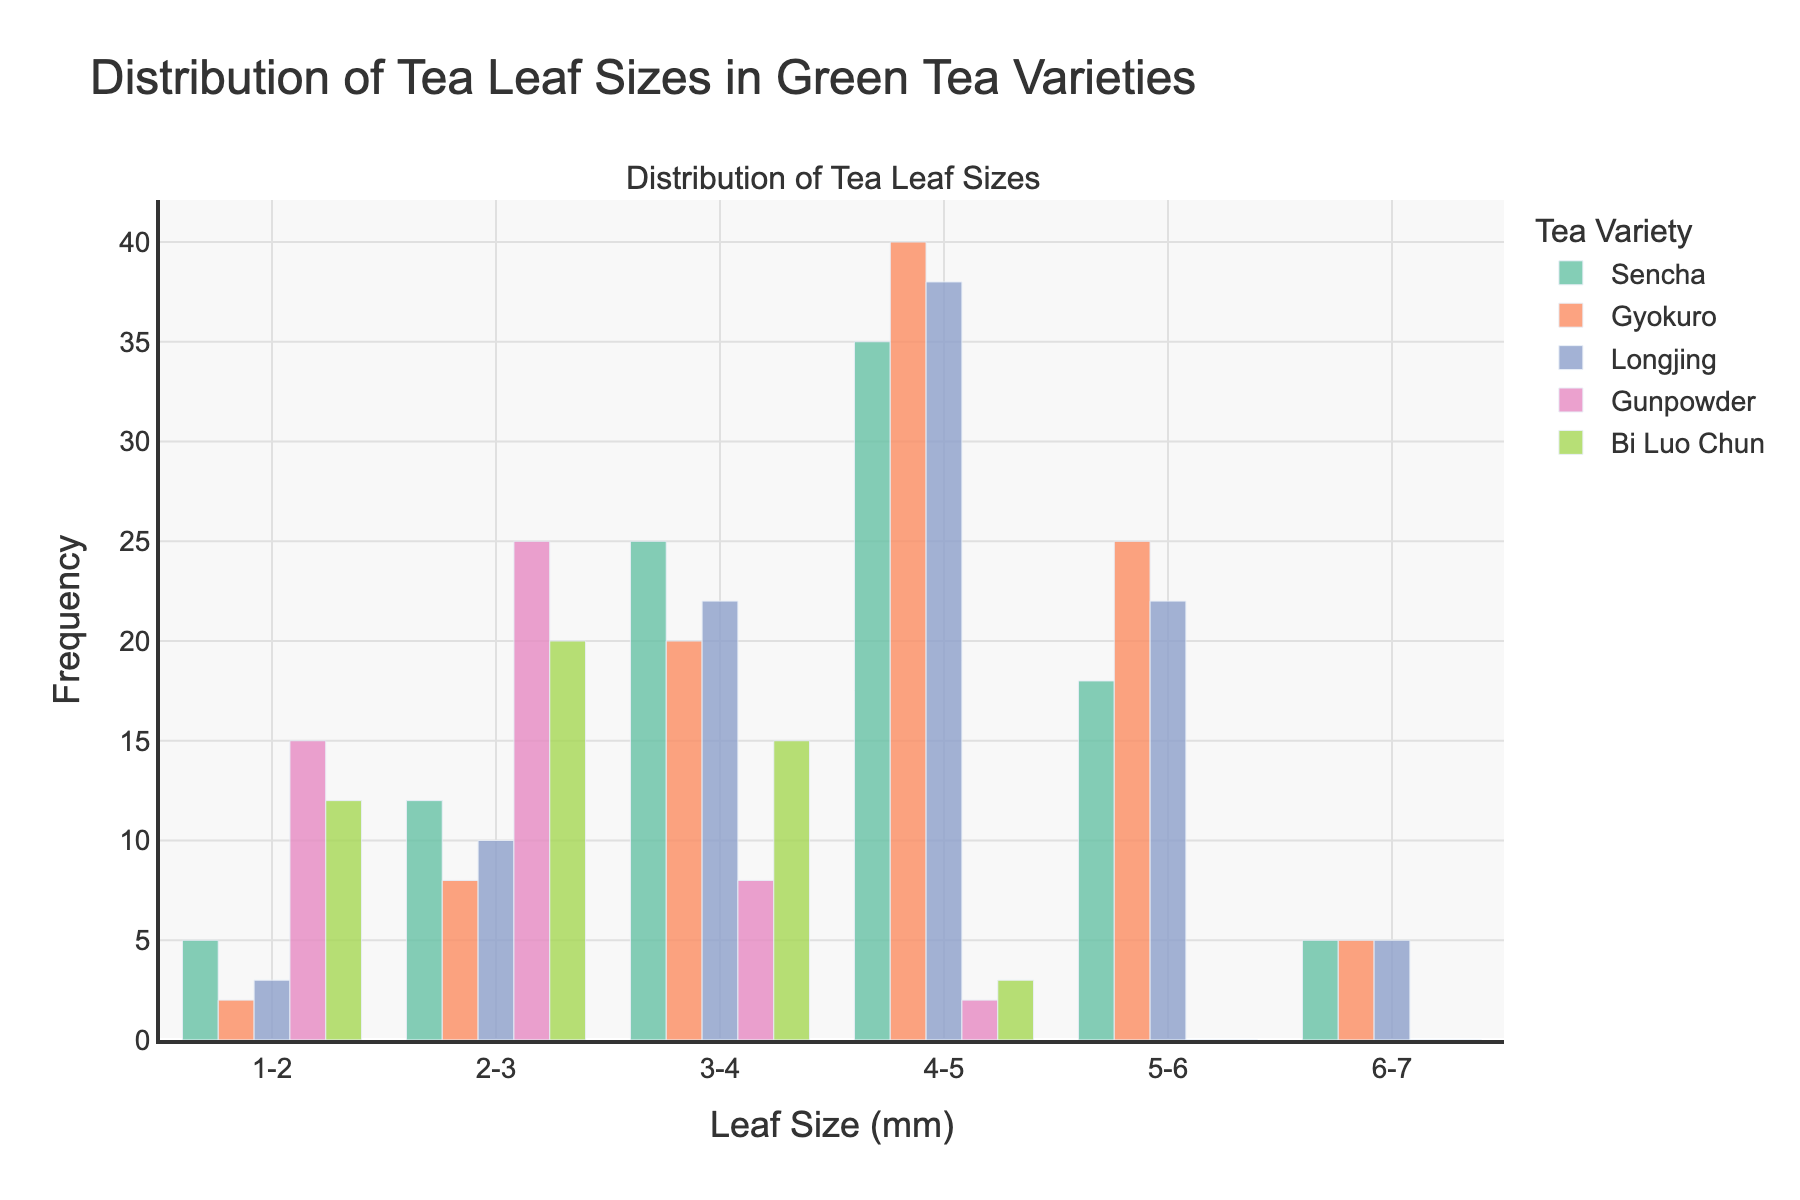How many tea varieties are represented in the figure? The figure includes bars of different colors representing tea varieties. Counting all different color bars, we identify 5 unique tea varieties.
Answer: 5 What is the title of the plot? The title of the plot is clearly stated at the top of the figure.
Answer: Distribution of Tea Leaf Sizes in Green Tea Varieties Which tea variety has the highest frequency in the 4-5 mm leaf size range? Looking at the 4-5 mm group, the bar representing Gyokuro is the tallest.
Answer: Gyokuro For the leaf size range 2-3 mm, what is the total frequency across all tea varieties? Adding up the heights of the bars for all tea varieties in the 2-3 mm category: 12 (Sencha) + 8 (Gyokuro) + 10 (Longjing) + 25 (Gunpowder) + 20 (Bi Luo Chun) = 75.
Answer: 75 Which leaf size range has the highest total frequency across all varieties? For each leaf size range, sum the frequencies of all tea varieties:
1-2 mm: 5+2+3+15+12=37 
2-3 mm: 75 
3-4 mm: 90 
4-5 mm: 118 
5-6 mm: 65 
6-7 mm: 15. 
Therefore, the 4-5 mm leaf size range has the highest total frequency.
Answer: 4-5 mm Which two tea varieties have equal frequencies in the 6-7 mm leaf size range? Observing the bars in the 6-7 mm range, both Sencha and Gyokuro have bars of equal height (5).
Answer: Sencha and Gyokuro Compare the frequency of Sencha and Gunpowder in the 3-4 mm leaf size range. The height of the Sencha bar is 25 and the height of the Gunpowder bar is 8 in the 3-4 mm range. Sencha’s frequency is higher.
Answer: Sencha In which leaf size range does Gunpowder have the highest frequency? By examining the heights of the Gunpowder bars across all ranges, the 2-3 mm range has the highest bar (25).
Answer: 2-3 mm What is the combined frequency of Bi Luo Chun in the 3-4 mm and 4-5 mm leaf size ranges? Summing the frequencies of Bi Luo Chun in the 3-4 mm and 4-5 mm categories: 15 + 3 = 18.
Answer: 18 